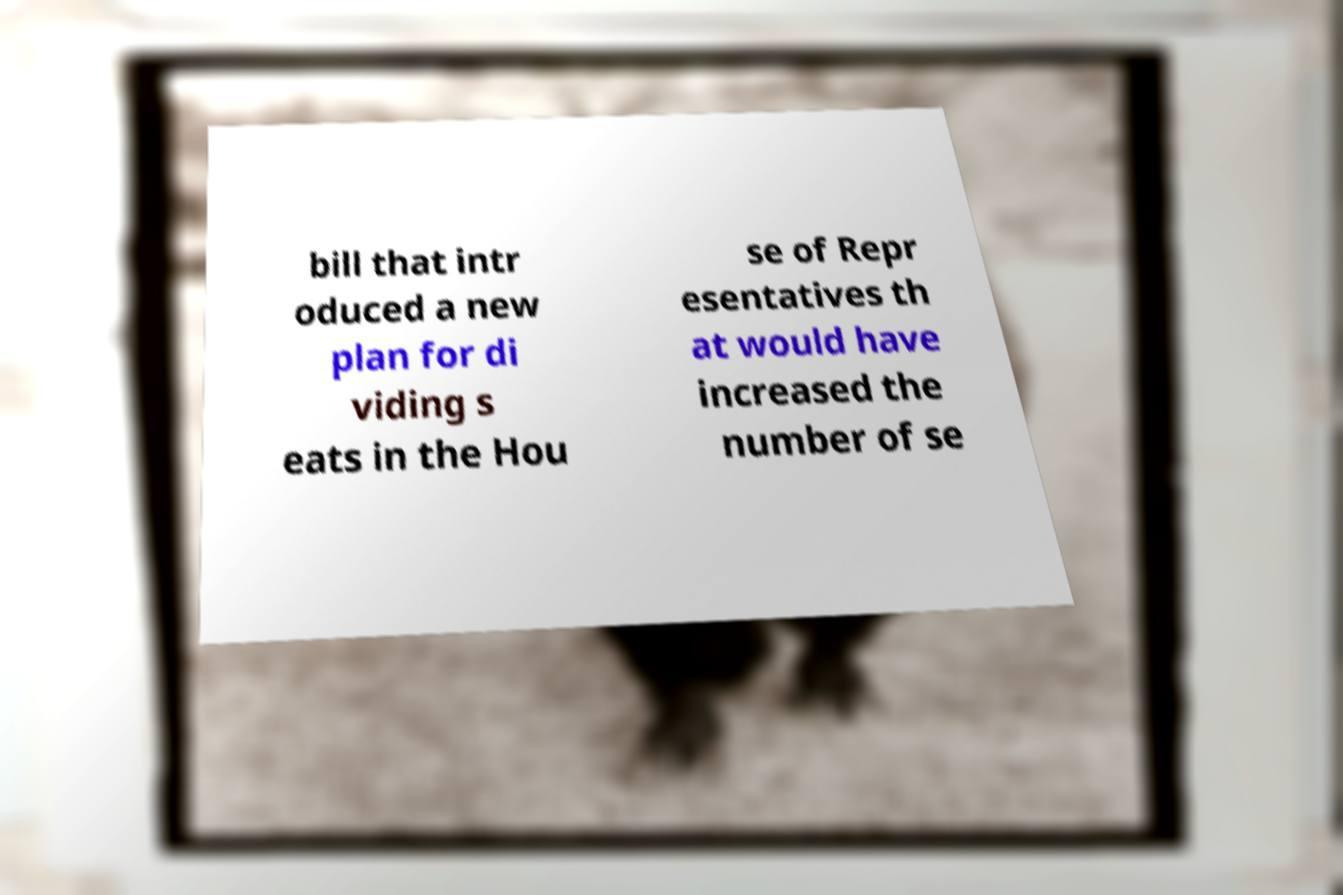I need the written content from this picture converted into text. Can you do that? bill that intr oduced a new plan for di viding s eats in the Hou se of Repr esentatives th at would have increased the number of se 